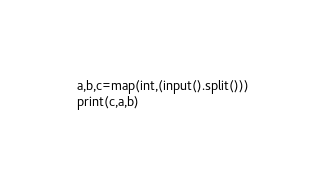Convert code to text. <code><loc_0><loc_0><loc_500><loc_500><_Python_>a,b,c=map(int,(input().split()))
print(c,a,b)</code> 